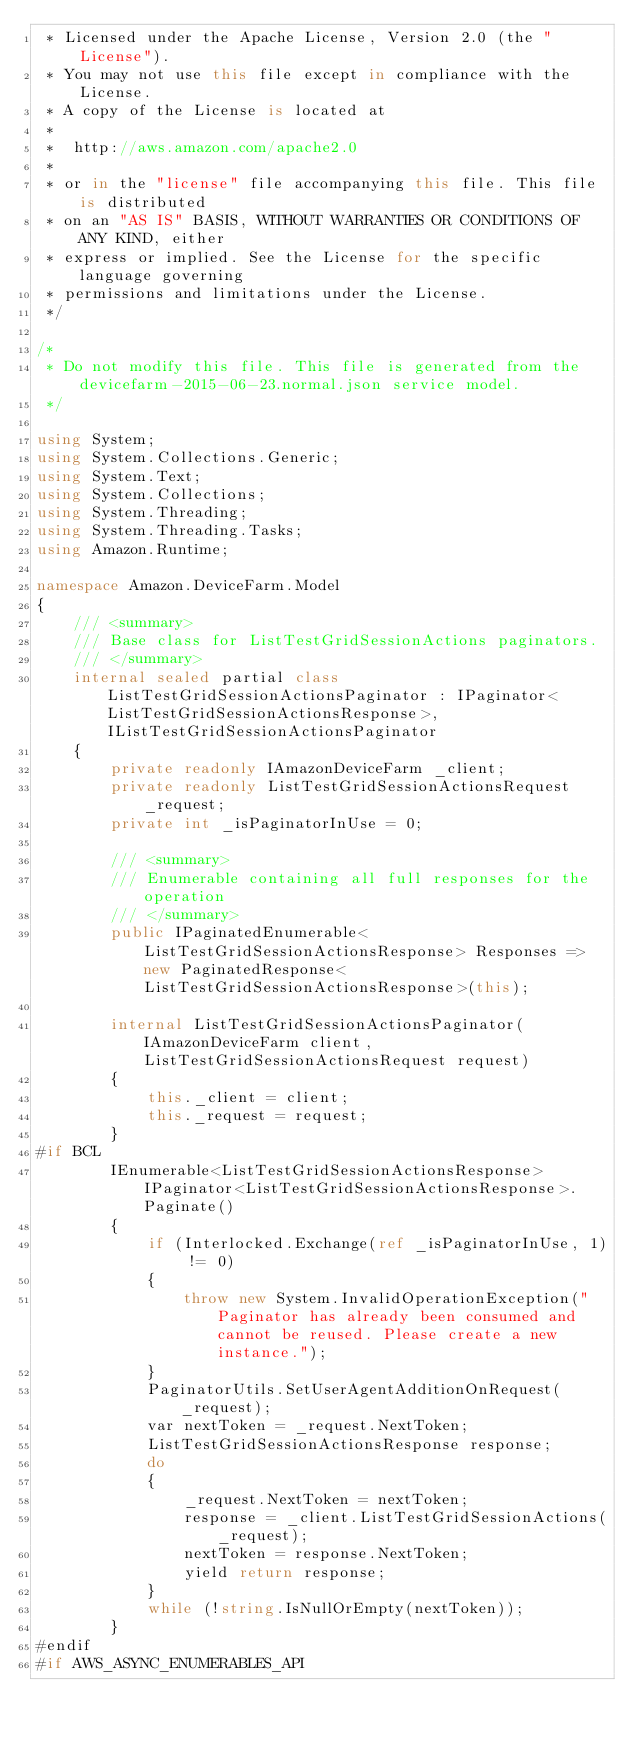Convert code to text. <code><loc_0><loc_0><loc_500><loc_500><_C#_> * Licensed under the Apache License, Version 2.0 (the "License").
 * You may not use this file except in compliance with the License.
 * A copy of the License is located at
 * 
 *  http://aws.amazon.com/apache2.0
 * 
 * or in the "license" file accompanying this file. This file is distributed
 * on an "AS IS" BASIS, WITHOUT WARRANTIES OR CONDITIONS OF ANY KIND, either
 * express or implied. See the License for the specific language governing
 * permissions and limitations under the License.
 */

/*
 * Do not modify this file. This file is generated from the devicefarm-2015-06-23.normal.json service model.
 */

using System;
using System.Collections.Generic;
using System.Text;
using System.Collections;
using System.Threading;
using System.Threading.Tasks;
using Amazon.Runtime;
 
namespace Amazon.DeviceFarm.Model
{
    /// <summary>
    /// Base class for ListTestGridSessionActions paginators.
    /// </summary>
    internal sealed partial class ListTestGridSessionActionsPaginator : IPaginator<ListTestGridSessionActionsResponse>, IListTestGridSessionActionsPaginator
    {
        private readonly IAmazonDeviceFarm _client;
        private readonly ListTestGridSessionActionsRequest _request;
        private int _isPaginatorInUse = 0;
        
        /// <summary>
        /// Enumerable containing all full responses for the operation
        /// </summary>
        public IPaginatedEnumerable<ListTestGridSessionActionsResponse> Responses => new PaginatedResponse<ListTestGridSessionActionsResponse>(this);

        internal ListTestGridSessionActionsPaginator(IAmazonDeviceFarm client, ListTestGridSessionActionsRequest request)
        {
            this._client = client;
            this._request = request;
        }
#if BCL
        IEnumerable<ListTestGridSessionActionsResponse> IPaginator<ListTestGridSessionActionsResponse>.Paginate()
        {
            if (Interlocked.Exchange(ref _isPaginatorInUse, 1) != 0)
            {
                throw new System.InvalidOperationException("Paginator has already been consumed and cannot be reused. Please create a new instance.");
            }
            PaginatorUtils.SetUserAgentAdditionOnRequest(_request);
            var nextToken = _request.NextToken;
            ListTestGridSessionActionsResponse response;
            do
            {
                _request.NextToken = nextToken;
                response = _client.ListTestGridSessionActions(_request);
                nextToken = response.NextToken;
                yield return response;
            }
            while (!string.IsNullOrEmpty(nextToken));
        }
#endif
#if AWS_ASYNC_ENUMERABLES_API</code> 